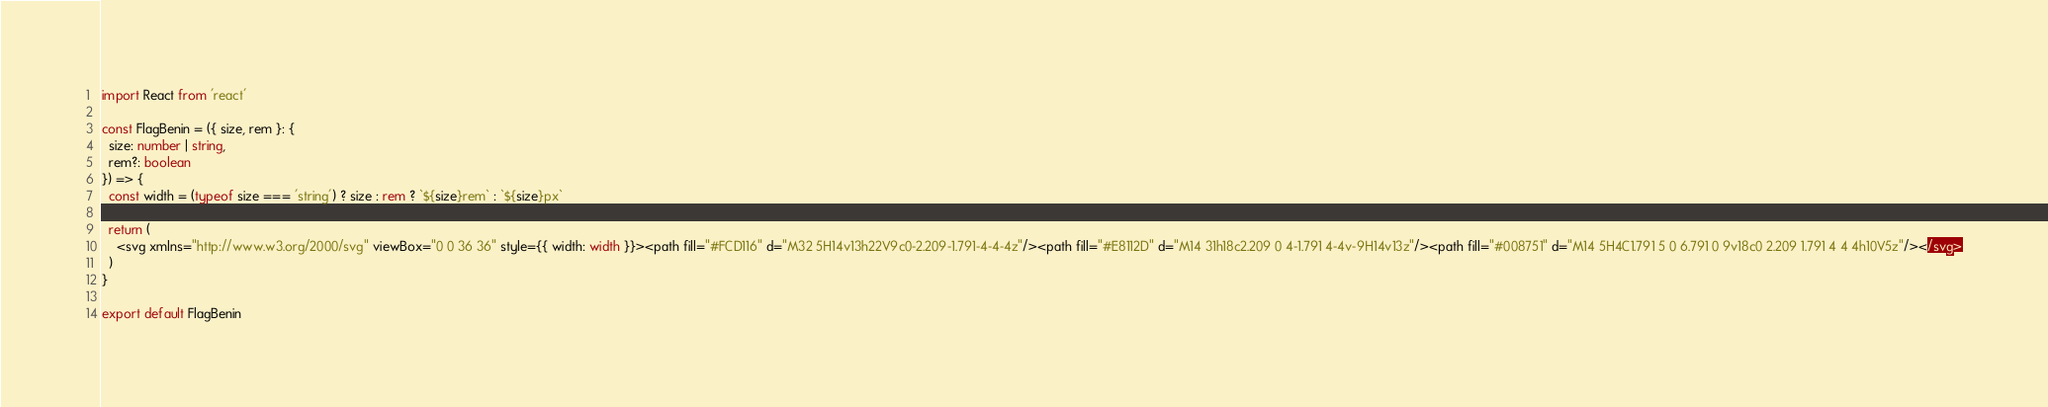Convert code to text. <code><loc_0><loc_0><loc_500><loc_500><_TypeScript_>import React from 'react'

const FlagBenin = ({ size, rem }: {
  size: number | string,
  rem?: boolean
}) => {
  const width = (typeof size === 'string') ? size : rem ? `${size}rem` : `${size}px`

  return (
    <svg xmlns="http://www.w3.org/2000/svg" viewBox="0 0 36 36" style={{ width: width }}><path fill="#FCD116" d="M32 5H14v13h22V9c0-2.209-1.791-4-4-4z"/><path fill="#E8112D" d="M14 31h18c2.209 0 4-1.791 4-4v-9H14v13z"/><path fill="#008751" d="M14 5H4C1.791 5 0 6.791 0 9v18c0 2.209 1.791 4 4 4h10V5z"/></svg>
  )
}

export default FlagBenin
</code> 